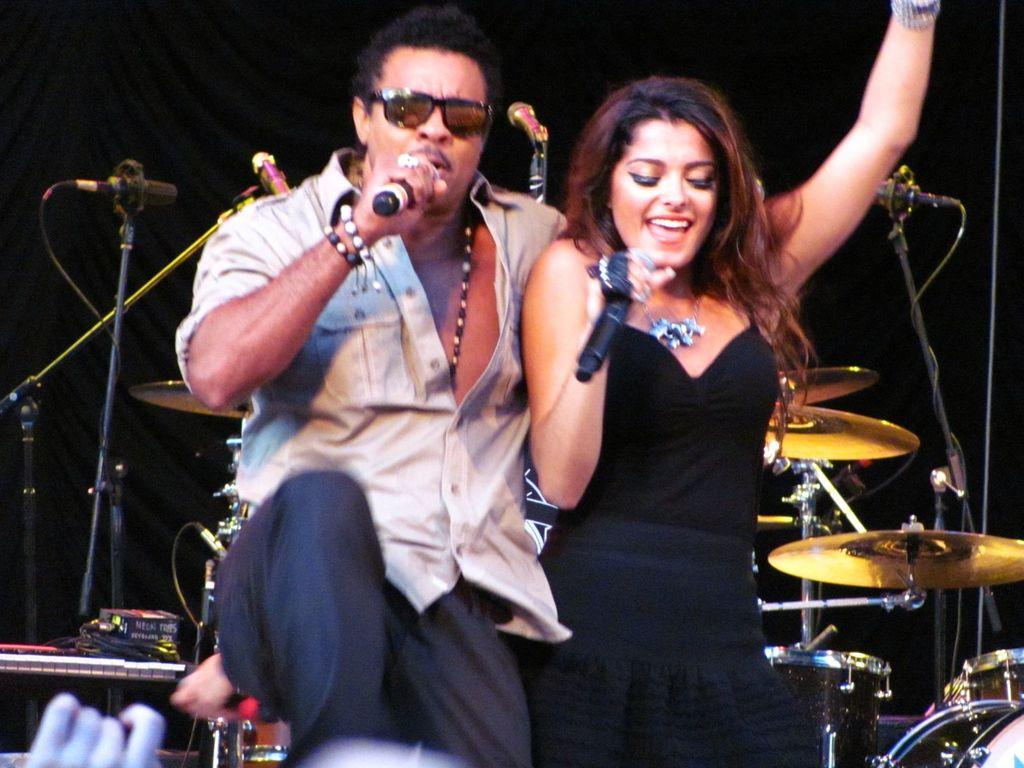How many people are in the image? There are two persons in the image. What are the two persons holding? The two persons are holding microphones. What else can be seen in the image besides the people and microphones? There are musical instruments visible in the image. What type of apparel is the person wearing while jumping into the water in the image? There is no person jumping into the water in the image, nor is there any apparel mentioned. 